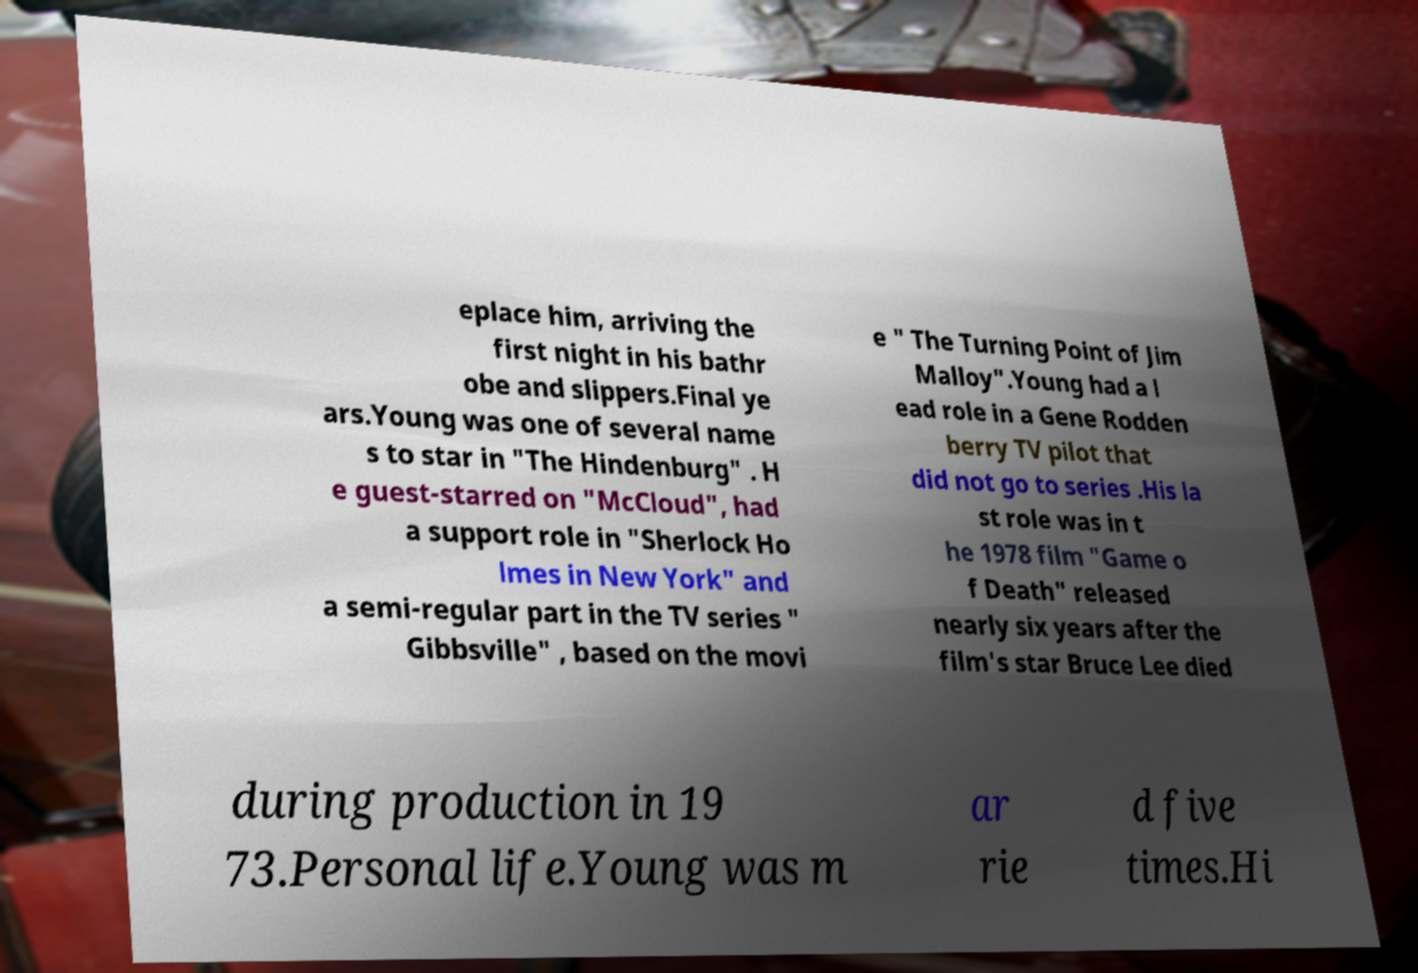Can you accurately transcribe the text from the provided image for me? eplace him, arriving the first night in his bathr obe and slippers.Final ye ars.Young was one of several name s to star in "The Hindenburg" . H e guest-starred on "McCloud", had a support role in "Sherlock Ho lmes in New York" and a semi-regular part in the TV series " Gibbsville" , based on the movi e " The Turning Point of Jim Malloy".Young had a l ead role in a Gene Rodden berry TV pilot that did not go to series .His la st role was in t he 1978 film "Game o f Death" released nearly six years after the film's star Bruce Lee died during production in 19 73.Personal life.Young was m ar rie d five times.Hi 